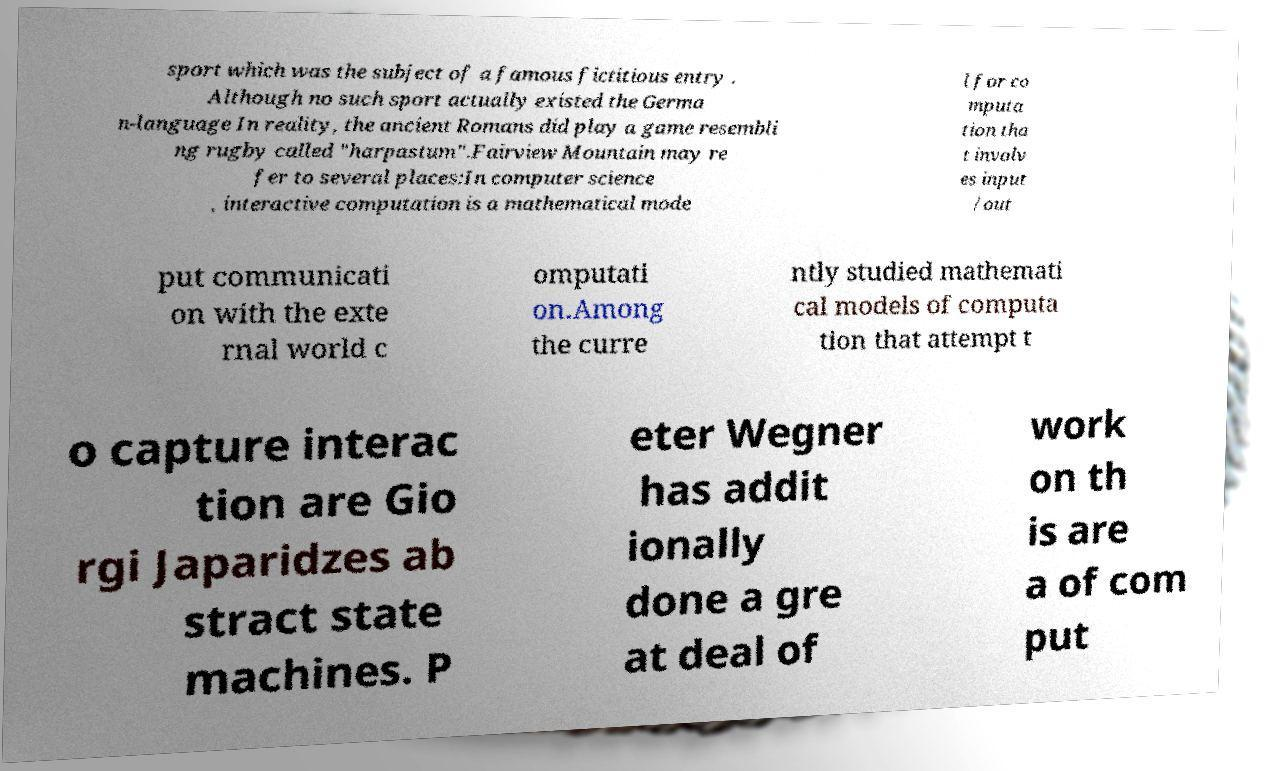I need the written content from this picture converted into text. Can you do that? sport which was the subject of a famous fictitious entry . Although no such sport actually existed the Germa n-language In reality, the ancient Romans did play a game resembli ng rugby called "harpastum".Fairview Mountain may re fer to several places:In computer science , interactive computation is a mathematical mode l for co mputa tion tha t involv es input /out put communicati on with the exte rnal world c omputati on.Among the curre ntly studied mathemati cal models of computa tion that attempt t o capture interac tion are Gio rgi Japaridzes ab stract state machines. P eter Wegner has addit ionally done a gre at deal of work on th is are a of com put 